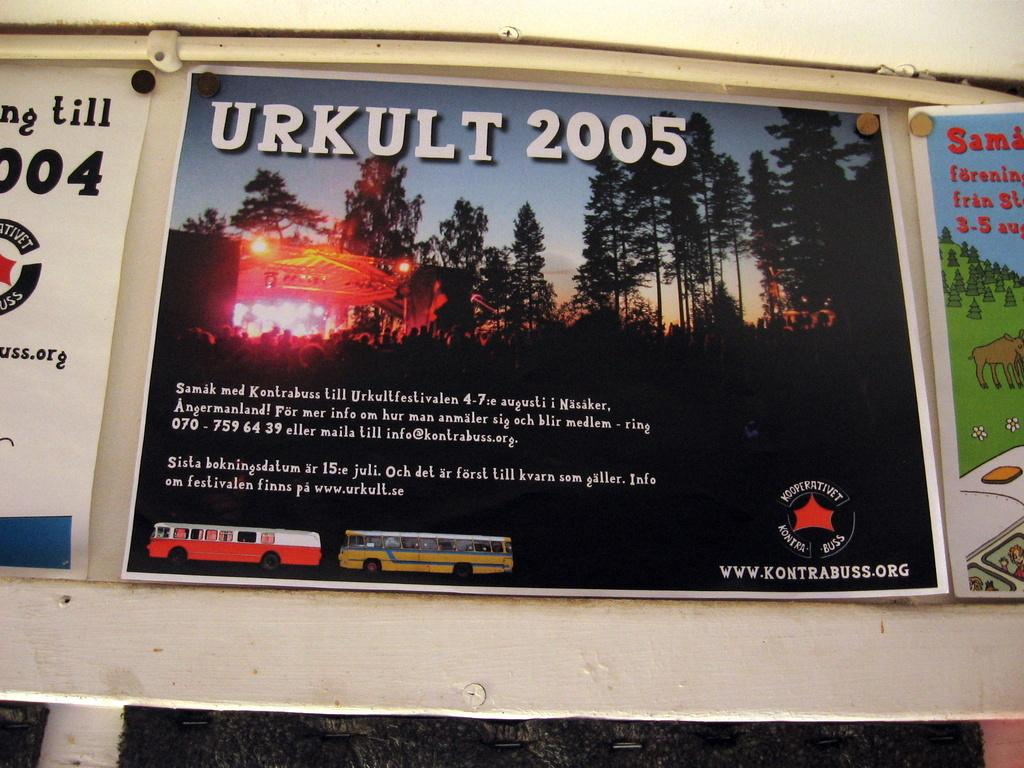<image>
Render a clear and concise summary of the photo. An advertisement in a foreign language that says Urkult 2005 